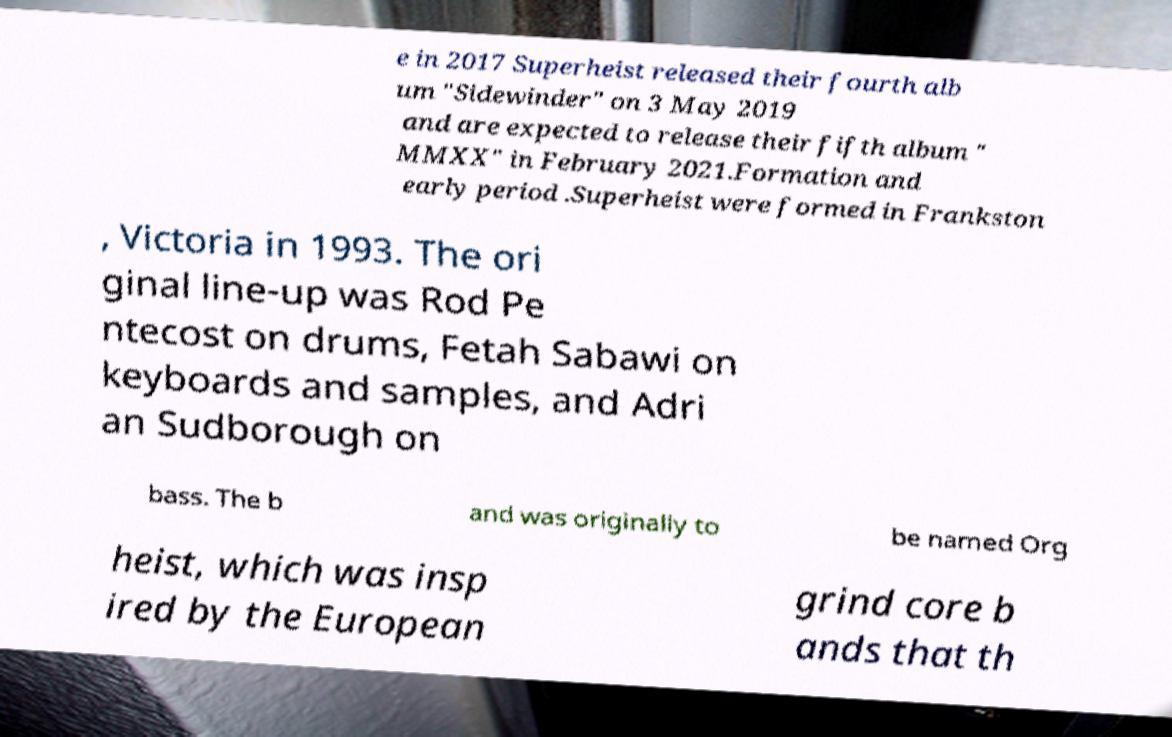Could you assist in decoding the text presented in this image and type it out clearly? e in 2017 Superheist released their fourth alb um "Sidewinder" on 3 May 2019 and are expected to release their fifth album " MMXX" in February 2021.Formation and early period .Superheist were formed in Frankston , Victoria in 1993. The ori ginal line-up was Rod Pe ntecost on drums, Fetah Sabawi on keyboards and samples, and Adri an Sudborough on bass. The b and was originally to be named Org heist, which was insp ired by the European grind core b ands that th 